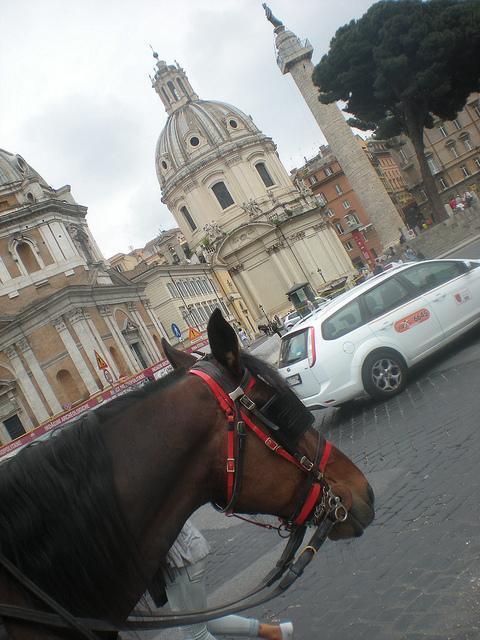How many yellow signs are in the photo?
Give a very brief answer. 1. How many cars can you see?
Give a very brief answer. 1. 